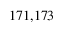Convert formula to latex. <formula><loc_0><loc_0><loc_500><loc_500>^ { 1 7 1 , 1 7 3 }</formula> 